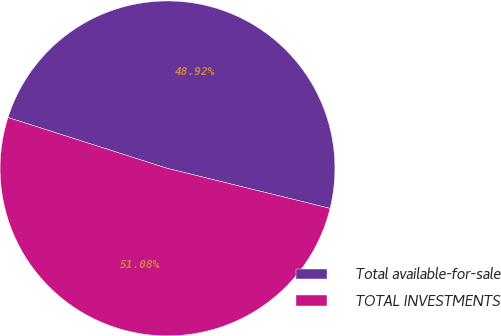<chart> <loc_0><loc_0><loc_500><loc_500><pie_chart><fcel>Total available-for-sale<fcel>TOTAL INVESTMENTS<nl><fcel>48.92%<fcel>51.08%<nl></chart> 